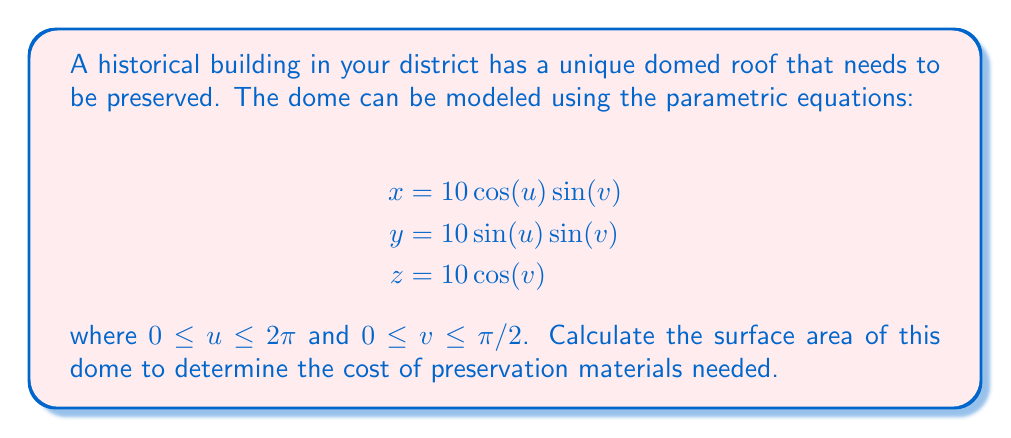Show me your answer to this math problem. To find the surface area of the dome, we need to use the formula for surface area in parametric form:

$$A = \int\int_D \left|\frac{\partial \mathbf{r}}{\partial u} \times \frac{\partial \mathbf{r}}{\partial v}\right| du dv$$

where $\mathbf{r}(u,v) = (x(u,v), y(u,v), z(u,v))$ is the parametric representation of the surface.

Step 1: Calculate the partial derivatives
$$\frac{\partial \mathbf{r}}{\partial u} = (-10\sin(u)\sin(v), 10\cos(u)\sin(v), 0)$$
$$\frac{\partial \mathbf{r}}{\partial v} = (10\cos(u)\cos(v), 10\sin(u)\cos(v), -10\sin(v))$$

Step 2: Calculate the cross product
$$\frac{\partial \mathbf{r}}{\partial u} \times \frac{\partial \mathbf{r}}{\partial v} = (100\cos(u)\sin^2(v), 100\sin(u)\sin^2(v), 100\sin(v)\cos(v))$$

Step 3: Calculate the magnitude of the cross product
$$\left|\frac{\partial \mathbf{r}}{\partial u} \times \frac{\partial \mathbf{r}}{\partial v}\right| = 100\sin(v)$$

Step 4: Set up the double integral
$$A = \int_0^{\pi/2} \int_0^{2\pi} 100\sin(v) du dv$$

Step 5: Evaluate the integral
$$A = 100 \int_0^{\pi/2} \int_0^{2\pi} \sin(v) du dv$$
$$A = 100 \cdot 2\pi \int_0^{\pi/2} \sin(v) dv$$
$$A = 200\pi [-\cos(v)]_0^{\pi/2}$$
$$A = 200\pi [-(0) - (-1)]$$
$$A = 200\pi$$

Therefore, the surface area of the dome is $200\pi$ square units.
Answer: $200\pi$ square units 